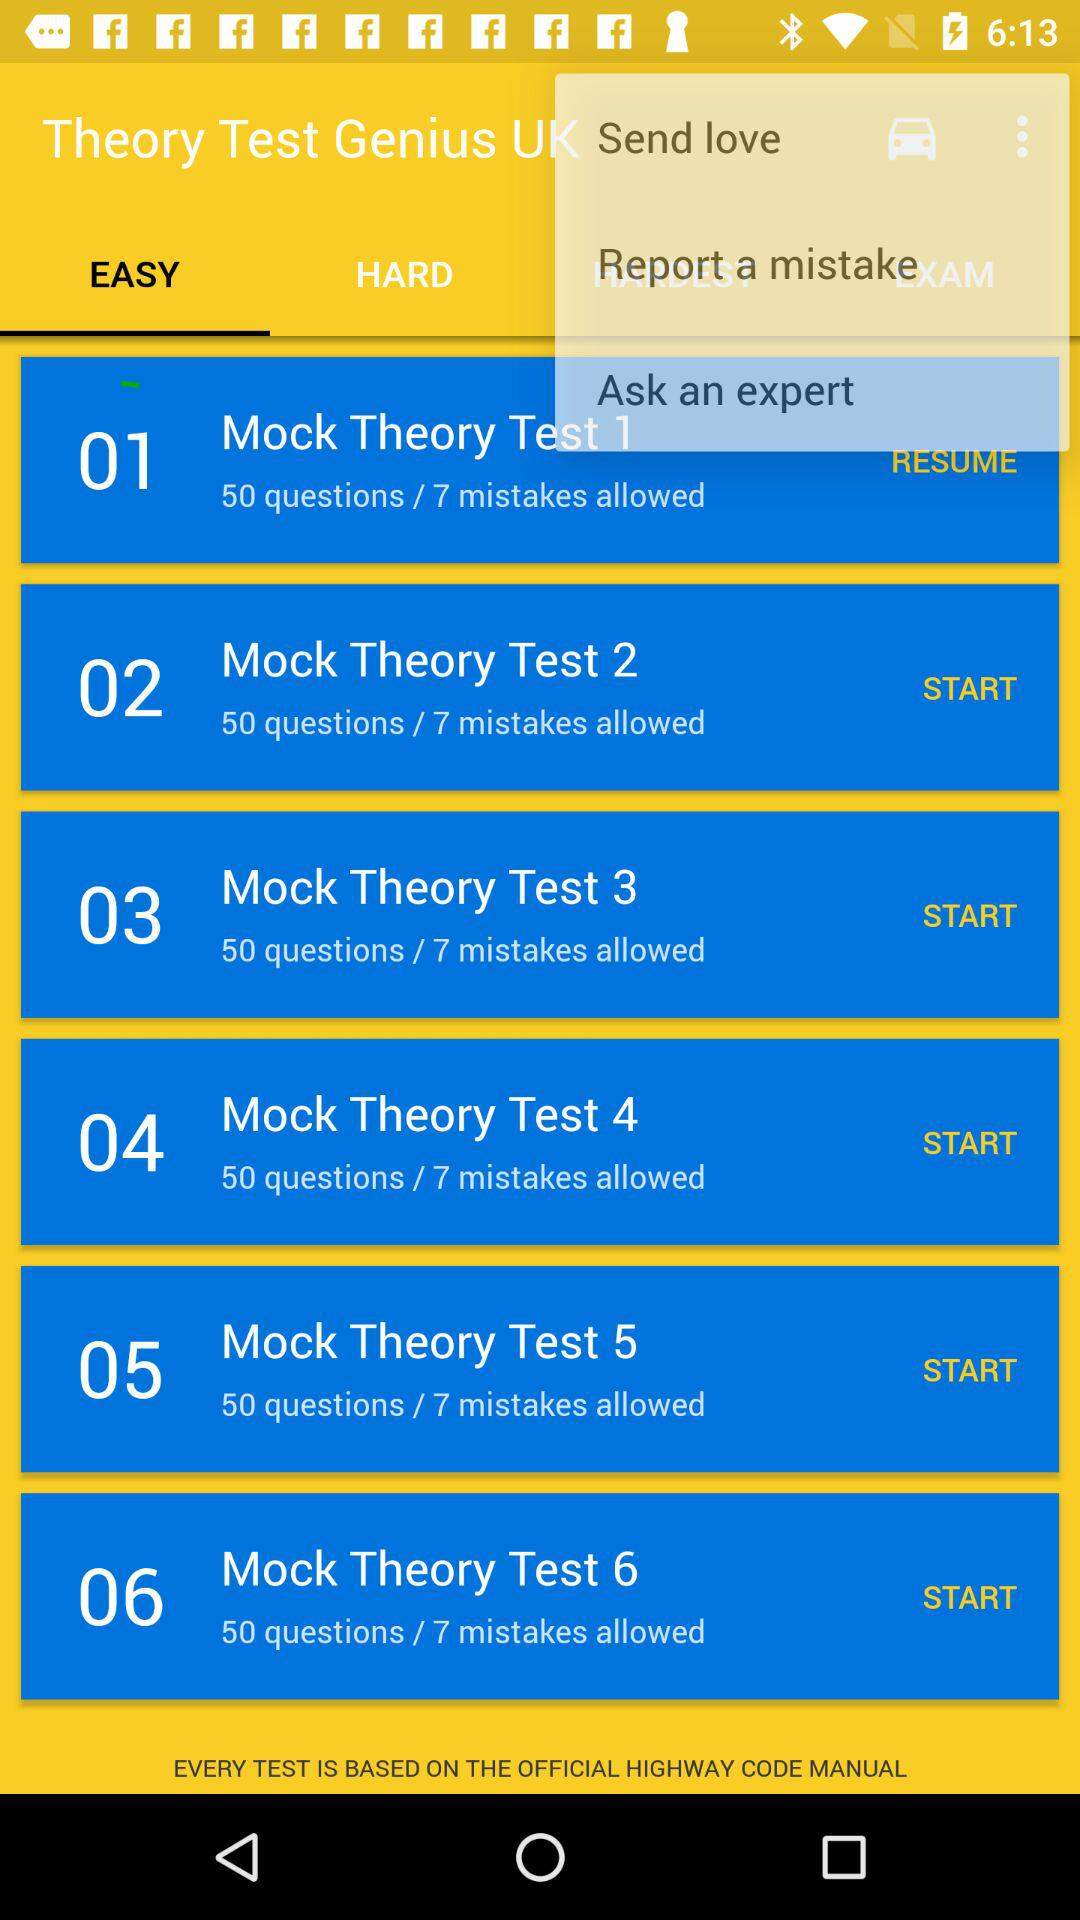How many questions are in "Mock Theory Test 2"? There are 50 questions in "Mock Theory Test 2". 